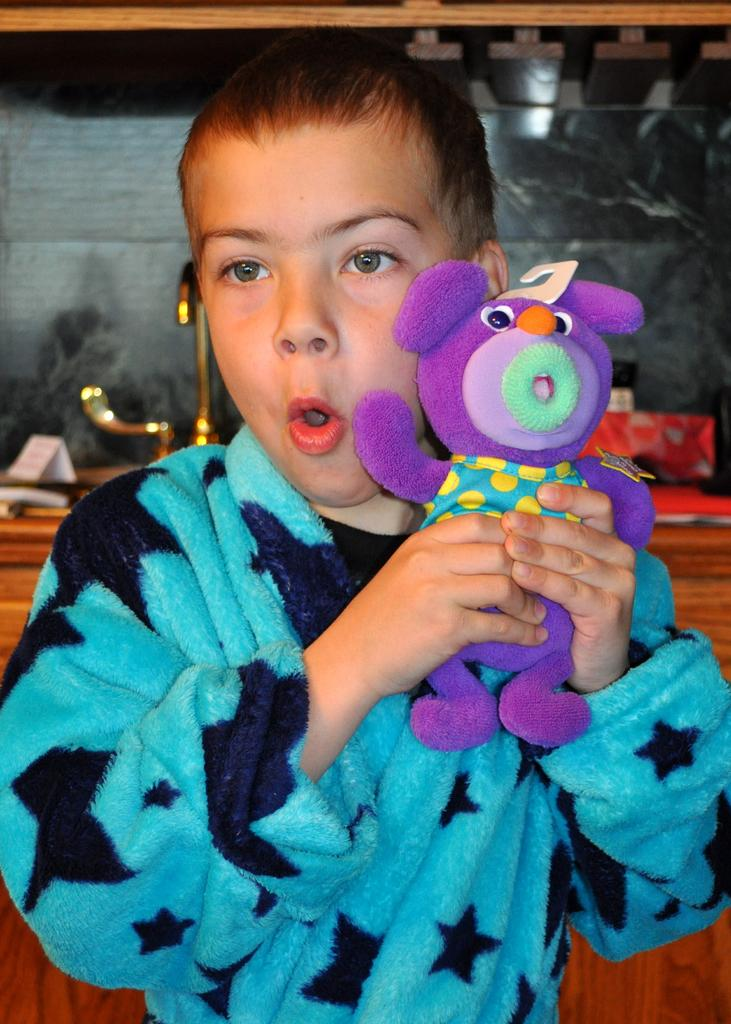What is the main subject of the image? The main subject of the image is a kid. What is the kid holding in the image? The kid is holding a toy. What can be seen in the background of the image? There is a wooden table in the background. What is on the wooden table? There are items on the wooden table. What type of shade does the kid discover in the image? There is no shade present in the image, nor is there any indication of the kid discovering anything. 